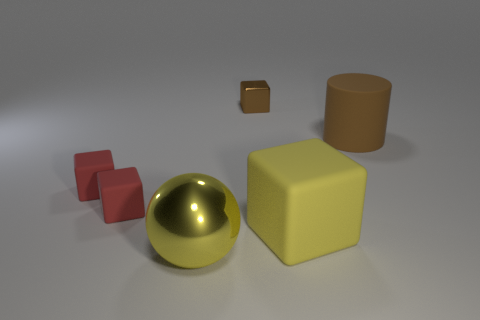How many other objects are the same material as the yellow block?
Provide a succinct answer. 3. There is a object right of the yellow block; how big is it?
Give a very brief answer. Large. Does the big metallic thing have the same color as the big rubber cylinder?
Make the answer very short. No. What number of small objects are brown cubes or blocks?
Ensure brevity in your answer.  3. Are there any other things of the same color as the big matte cube?
Your answer should be compact. Yes. Are there any big shiny things behind the big shiny ball?
Keep it short and to the point. No. What size is the shiny object that is right of the yellow thing left of the brown metallic object?
Offer a very short reply. Small. Are there the same number of small brown metallic things that are right of the brown rubber object and cylinders that are behind the large yellow sphere?
Keep it short and to the point. No. Are there any big shiny balls that are behind the big yellow object behind the big ball?
Ensure brevity in your answer.  No. There is a yellow object left of the tiny thing to the right of the yellow shiny ball; how many matte cubes are behind it?
Ensure brevity in your answer.  3. 